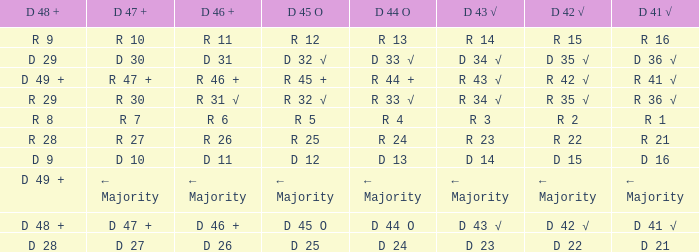What is the value of D 43 √ when the value of D 42 √ is d 42 √? D 43 √. 